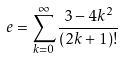Convert formula to latex. <formula><loc_0><loc_0><loc_500><loc_500>e = \sum _ { k = 0 } ^ { \infty } \frac { 3 - 4 k ^ { 2 } } { ( 2 k + 1 ) ! }</formula> 